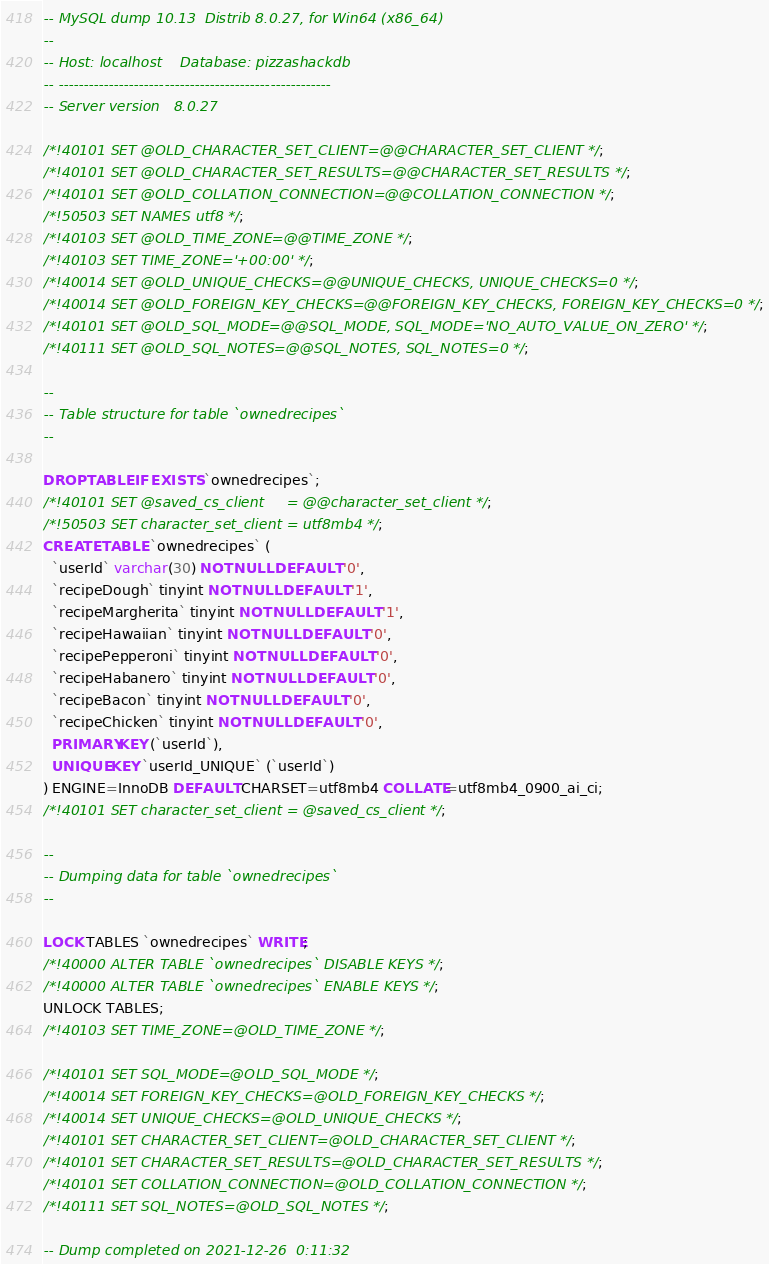Convert code to text. <code><loc_0><loc_0><loc_500><loc_500><_SQL_>-- MySQL dump 10.13  Distrib 8.0.27, for Win64 (x86_64)
--
-- Host: localhost    Database: pizzashackdb
-- ------------------------------------------------------
-- Server version	8.0.27

/*!40101 SET @OLD_CHARACTER_SET_CLIENT=@@CHARACTER_SET_CLIENT */;
/*!40101 SET @OLD_CHARACTER_SET_RESULTS=@@CHARACTER_SET_RESULTS */;
/*!40101 SET @OLD_COLLATION_CONNECTION=@@COLLATION_CONNECTION */;
/*!50503 SET NAMES utf8 */;
/*!40103 SET @OLD_TIME_ZONE=@@TIME_ZONE */;
/*!40103 SET TIME_ZONE='+00:00' */;
/*!40014 SET @OLD_UNIQUE_CHECKS=@@UNIQUE_CHECKS, UNIQUE_CHECKS=0 */;
/*!40014 SET @OLD_FOREIGN_KEY_CHECKS=@@FOREIGN_KEY_CHECKS, FOREIGN_KEY_CHECKS=0 */;
/*!40101 SET @OLD_SQL_MODE=@@SQL_MODE, SQL_MODE='NO_AUTO_VALUE_ON_ZERO' */;
/*!40111 SET @OLD_SQL_NOTES=@@SQL_NOTES, SQL_NOTES=0 */;

--
-- Table structure for table `ownedrecipes`
--

DROP TABLE IF EXISTS `ownedrecipes`;
/*!40101 SET @saved_cs_client     = @@character_set_client */;
/*!50503 SET character_set_client = utf8mb4 */;
CREATE TABLE `ownedrecipes` (
  `userId` varchar(30) NOT NULL DEFAULT '0',
  `recipeDough` tinyint NOT NULL DEFAULT '1',
  `recipeMargherita` tinyint NOT NULL DEFAULT '1',
  `recipeHawaiian` tinyint NOT NULL DEFAULT '0',
  `recipePepperoni` tinyint NOT NULL DEFAULT '0',
  `recipeHabanero` tinyint NOT NULL DEFAULT '0',
  `recipeBacon` tinyint NOT NULL DEFAULT '0',
  `recipeChicken` tinyint NOT NULL DEFAULT '0',
  PRIMARY KEY (`userId`),
  UNIQUE KEY `userId_UNIQUE` (`userId`)
) ENGINE=InnoDB DEFAULT CHARSET=utf8mb4 COLLATE=utf8mb4_0900_ai_ci;
/*!40101 SET character_set_client = @saved_cs_client */;

--
-- Dumping data for table `ownedrecipes`
--

LOCK TABLES `ownedrecipes` WRITE;
/*!40000 ALTER TABLE `ownedrecipes` DISABLE KEYS */;
/*!40000 ALTER TABLE `ownedrecipes` ENABLE KEYS */;
UNLOCK TABLES;
/*!40103 SET TIME_ZONE=@OLD_TIME_ZONE */;

/*!40101 SET SQL_MODE=@OLD_SQL_MODE */;
/*!40014 SET FOREIGN_KEY_CHECKS=@OLD_FOREIGN_KEY_CHECKS */;
/*!40014 SET UNIQUE_CHECKS=@OLD_UNIQUE_CHECKS */;
/*!40101 SET CHARACTER_SET_CLIENT=@OLD_CHARACTER_SET_CLIENT */;
/*!40101 SET CHARACTER_SET_RESULTS=@OLD_CHARACTER_SET_RESULTS */;
/*!40101 SET COLLATION_CONNECTION=@OLD_COLLATION_CONNECTION */;
/*!40111 SET SQL_NOTES=@OLD_SQL_NOTES */;

-- Dump completed on 2021-12-26  0:11:32
</code> 